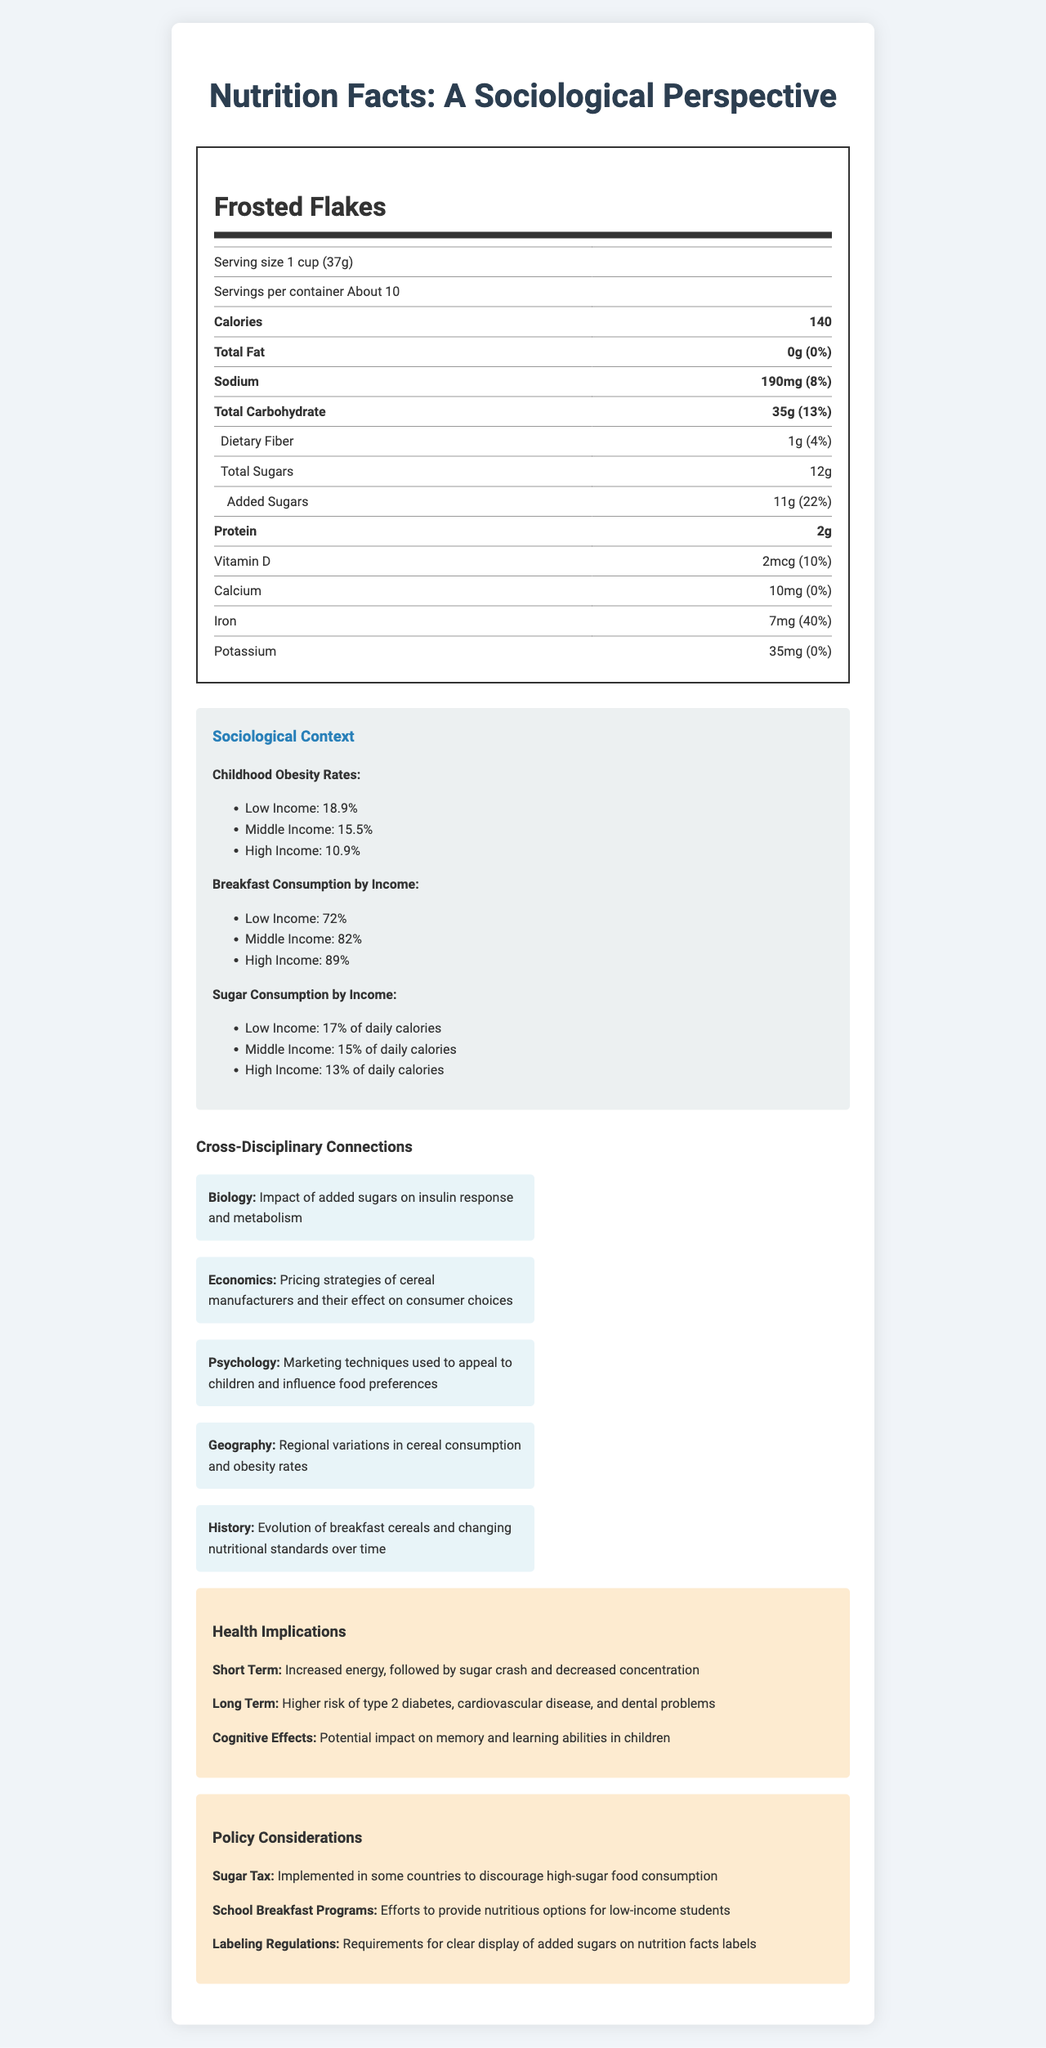What is the serving size of Frosted Flakes? The document mentions that the serving size is 1 cup (37g).
Answer: 1 cup (37g) What is the percentage of Daily Value of added sugars in Frosted Flakes? The document states that the percent Daily Value of added sugars is 22%.
Answer: 22% How many grams of protein are in one serving of Frosted Flakes? The document shows that one serving contains 2 grams of protein.
Answer: 2 grams What is the childhood obesity rate in low-income groups? According to the document, the childhood obesity rate in low-income groups is 18.9%.
Answer: 18.9% What are the amounts of calcium and iron in one serving of Frosted Flakes? The document lists calcium at 10mg and iron at 7mg per serving.
Answer: Calcium: 10mg, Iron: 7mg Which of the following is the highest percentage of daily values found in Frosted Flakes? A. Sodium B. Total Carbohydrate C. Iron The iron percent Daily Value is 40%, higher than sodium (8%) and total carbohydrate (13%).
Answer: C. Iron Which income group consumes the least amount of breakfast? 1. Low Income 2. Middle Income 3. High Income The document states that 72% of low-income individuals consume breakfast, which is less than middle-income (82%) and high-income (89%) groups.
Answer: 1. Low Income Does Frosted Flakes contain any dietary fiber? The document indicates that it contains 1g of dietary fiber, which is 4% of the daily value.
Answer: Yes What are the main health implications described for Frosted Flakes in the document? The document details short-term effects like energy spikes and crashes, long-term health risks such as type 2 diabetes, cardiovascular diseases, dental issues, and potential cognitive effects on memory and learning.
Answer: Increased energy followed by a sugar crash, higher risk of type 2 diabetes, cardiovascular disease, and dental problems; potential impact on memory and learning abilities. What is the exact cost of Frosted Flakes per container? The document provides nutritional information and sociological context but does not mention the price of Frosted Flakes.
Answer: Cannot be determined 